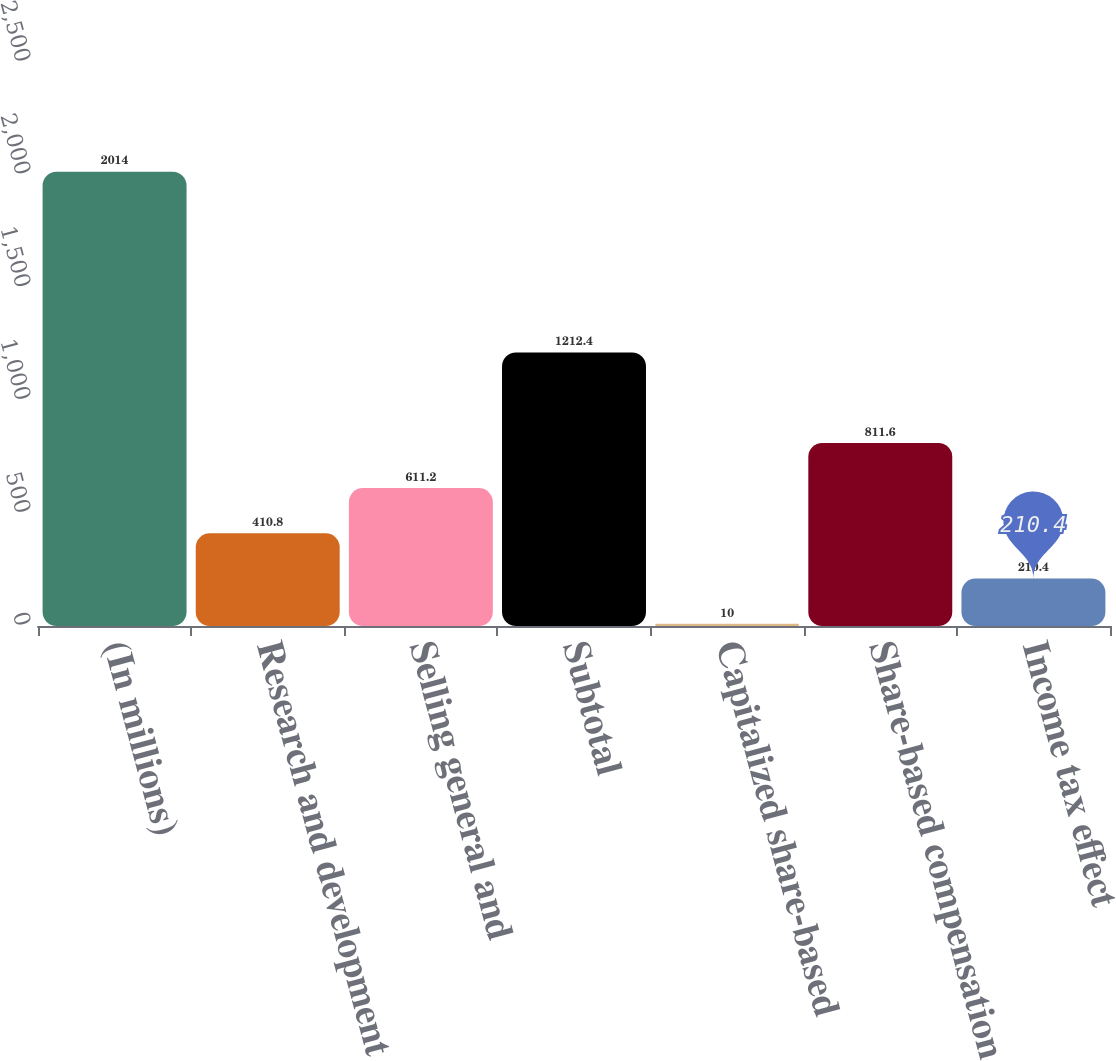Convert chart. <chart><loc_0><loc_0><loc_500><loc_500><bar_chart><fcel>(In millions)<fcel>Research and development<fcel>Selling general and<fcel>Subtotal<fcel>Capitalized share-based<fcel>Share-based compensation<fcel>Income tax effect<nl><fcel>2014<fcel>410.8<fcel>611.2<fcel>1212.4<fcel>10<fcel>811.6<fcel>210.4<nl></chart> 